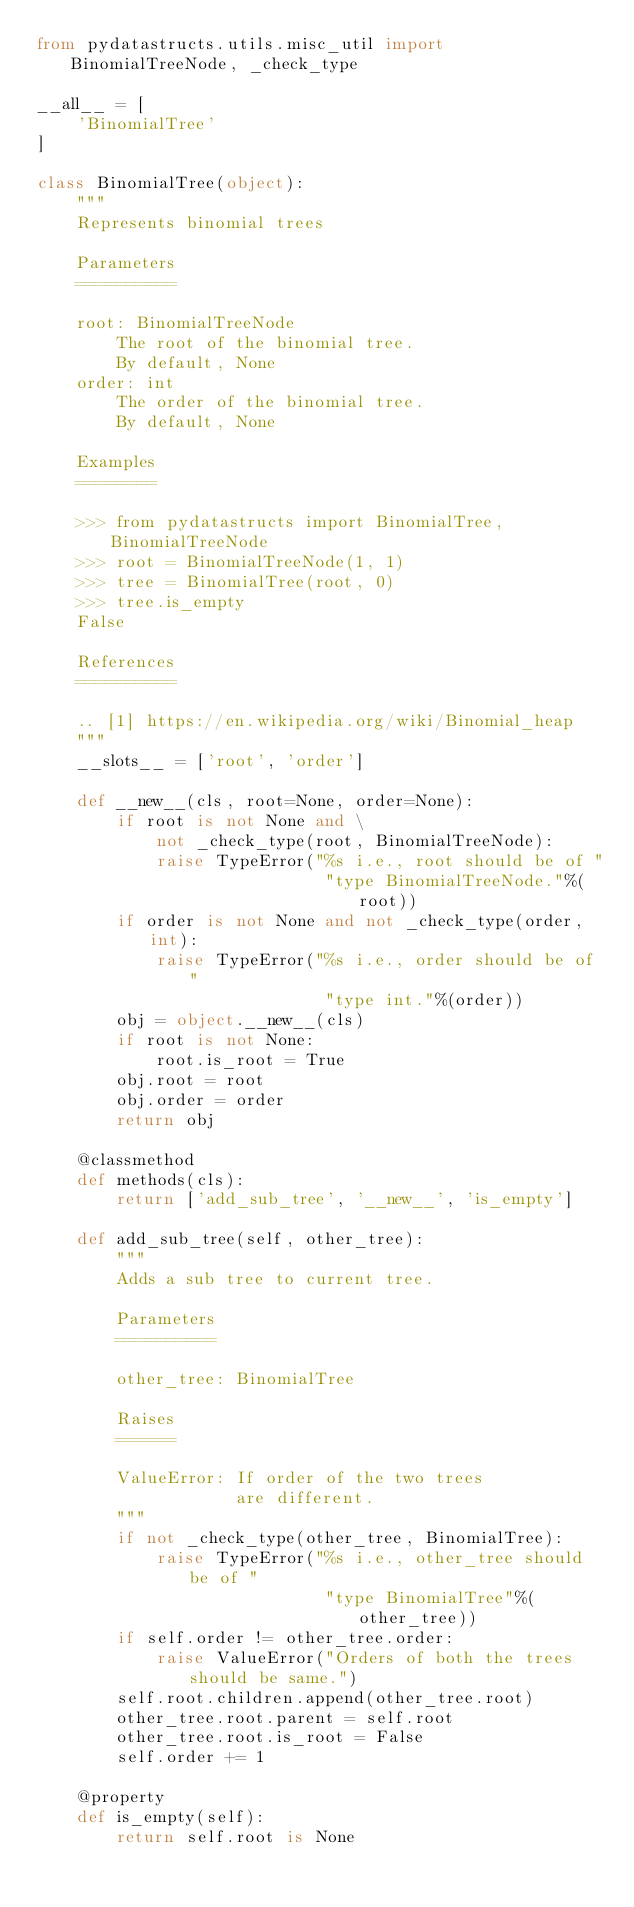Convert code to text. <code><loc_0><loc_0><loc_500><loc_500><_Python_>from pydatastructs.utils.misc_util import BinomialTreeNode, _check_type

__all__ = [
    'BinomialTree'
]

class BinomialTree(object):
    """
    Represents binomial trees

    Parameters
    ==========

    root: BinomialTreeNode
        The root of the binomial tree.
        By default, None
    order: int
        The order of the binomial tree.
        By default, None

    Examples
    ========

    >>> from pydatastructs import BinomialTree, BinomialTreeNode
    >>> root = BinomialTreeNode(1, 1)
    >>> tree = BinomialTree(root, 0)
    >>> tree.is_empty
    False

    References
    ==========

    .. [1] https://en.wikipedia.org/wiki/Binomial_heap
    """
    __slots__ = ['root', 'order']

    def __new__(cls, root=None, order=None):
        if root is not None and \
            not _check_type(root, BinomialTreeNode):
            raise TypeError("%s i.e., root should be of "
                             "type BinomialTreeNode."%(root))
        if order is not None and not _check_type(order, int):
            raise TypeError("%s i.e., order should be of "
                             "type int."%(order))
        obj = object.__new__(cls)
        if root is not None:
            root.is_root = True
        obj.root = root
        obj.order = order
        return obj

    @classmethod
    def methods(cls):
        return ['add_sub_tree', '__new__', 'is_empty']

    def add_sub_tree(self, other_tree):
        """
        Adds a sub tree to current tree.

        Parameters
        ==========

        other_tree: BinomialTree

        Raises
        ======

        ValueError: If order of the two trees
                    are different.
        """
        if not _check_type(other_tree, BinomialTree):
            raise TypeError("%s i.e., other_tree should be of "
                             "type BinomialTree"%(other_tree))
        if self.order != other_tree.order:
            raise ValueError("Orders of both the trees should be same.")
        self.root.children.append(other_tree.root)
        other_tree.root.parent = self.root
        other_tree.root.is_root = False
        self.order += 1

    @property
    def is_empty(self):
        return self.root is None
</code> 